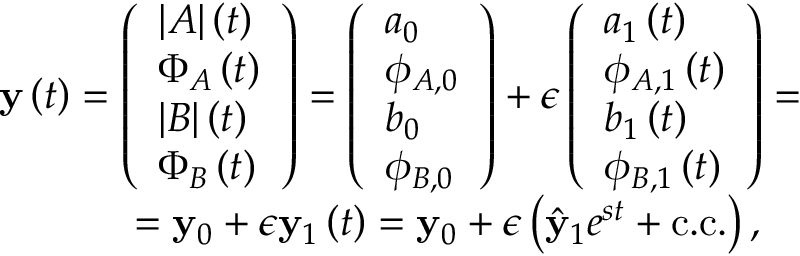<formula> <loc_0><loc_0><loc_500><loc_500>\begin{array} { r } { y \left ( t \right ) = \left ( \begin{array} { l } { | A | \left ( t \right ) } \\ { \Phi _ { A } \left ( t \right ) } \\ { | B | \left ( t \right ) } \\ { \Phi _ { B } \left ( t \right ) } \end{array} \right ) = \left ( \begin{array} { l } { a _ { 0 } } \\ { \phi _ { A , 0 } } \\ { b _ { 0 } } \\ { \phi _ { B , 0 } } \end{array} \right ) + \epsilon \left ( \begin{array} { l } { a _ { 1 } \left ( t \right ) } \\ { \phi _ { A , 1 } \left ( t \right ) } \\ { b _ { 1 } \left ( t \right ) } \\ { \phi _ { B , 1 } \left ( t \right ) } \end{array} \right ) = } \\ { = y _ { 0 } + \epsilon y _ { 1 } \left ( t \right ) = y _ { 0 } + \epsilon \left ( \hat { y } _ { 1 } e ^ { s t } + c . c . \right ) , \quad } \end{array}</formula> 